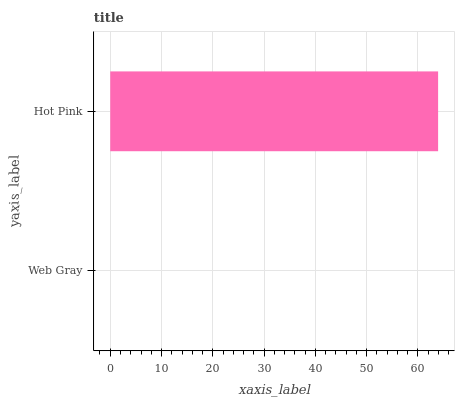Is Web Gray the minimum?
Answer yes or no. Yes. Is Hot Pink the maximum?
Answer yes or no. Yes. Is Hot Pink the minimum?
Answer yes or no. No. Is Hot Pink greater than Web Gray?
Answer yes or no. Yes. Is Web Gray less than Hot Pink?
Answer yes or no. Yes. Is Web Gray greater than Hot Pink?
Answer yes or no. No. Is Hot Pink less than Web Gray?
Answer yes or no. No. Is Hot Pink the high median?
Answer yes or no. Yes. Is Web Gray the low median?
Answer yes or no. Yes. Is Web Gray the high median?
Answer yes or no. No. Is Hot Pink the low median?
Answer yes or no. No. 